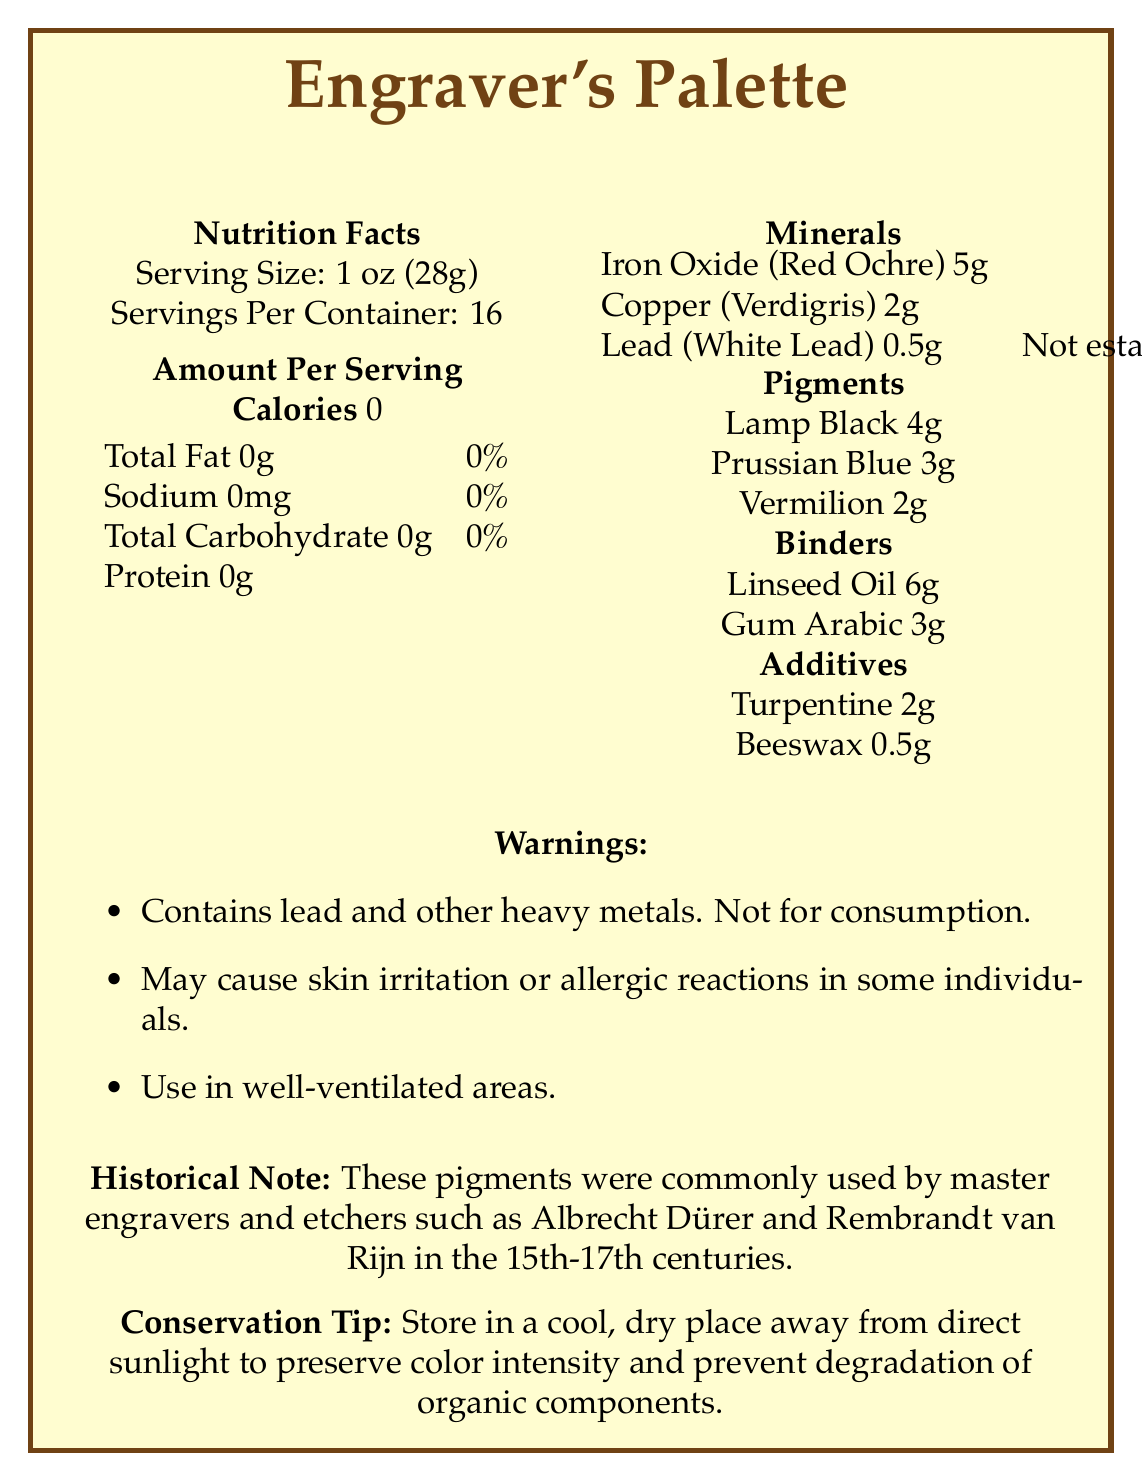What is the serving size listed on the document? The serving size indicated in the document under the "Nutrition Facts" section is 1 oz (28g).
Answer: 1 oz (28g) What is the total fat content per serving? The total fat content per serving is specified as 0g in the document's "Amount Per Serving" table.
Answer: 0g Which mineral is present in the largest amount per serving? According to the document under "Minerals," Iron Oxide (Red Ochre) is present in the largest amount at 5g per serving.
Answer: Iron Oxide (Red Ochre) Does this document contain nutritional information for consumable products? The document contains a warning stating "Not for consumption," implying these pigments are not meant to be consumed.
Answer: No What is the historical significance of these pigments? The document provides a historical note indicating their use by renowned engravers and etchers during the 15th-17th centuries.
Answer: These pigments were commonly used by master engravers and etchers such as Albrecht Dürer and Rembrandt van Rijn in the 15th-17th centuries. What percentage of the daily value for iron does one serving of this product provide? A. 22% B. 28% C. 18% D. Not established The document states that Iron Oxide (Red Ochre) provides 28% of the daily value for iron per serving.
Answer: B Which of the following pigments is present in the smallest amount per serving? I. Lamp Black II. Prussian Blue III. Vermilion The document lists vermilion as 2g per serving while Lamp Black is 4g and Prussian Blue is 3g.
Answer: III Is it recommended to store this product in a humid environment? The conservation tip advises storing in a cool, dry place away from direct sunlight.
Answer: No Summarize the main information given in this document. The document serves as a modern "nutrition label" for non-consumable pigments, listing various components per serving, their historical use, hazards, and conservation advice.
Answer: This document provides a "nutrition facts" styled label for pigments used in historic printmaking. It includes information on serving size, quantity of minerals, pigments, binders, and additives per serving, and warnings about the hazards of use. It also contains historical significance and conservation tips for these materials. What is the amount of Sodium per serving? The document specifies that Sodium content is 0mg per serving.
Answer: 0mg Which binder is used in the greatest quantity? Under the "Binders" section, Linseed Oil is listed at 6g, which is the highest quantity among the binders.
Answer: Linseed Oil Are there any substances with unestablished daily values listed? The document mentions Lead (White Lead) with a daily value of "Not established."
Answer: Yes Can you determine the exact color of the pigments used based on this document? While the document lists pigment names like "Lamp Black" and "Prussian Blue," it does not describe their exact visual colors or shades.
Answer: Not enough information Do these pigments provide any caloric content? According to the document, the calories per serving are 0.
Answer: No 